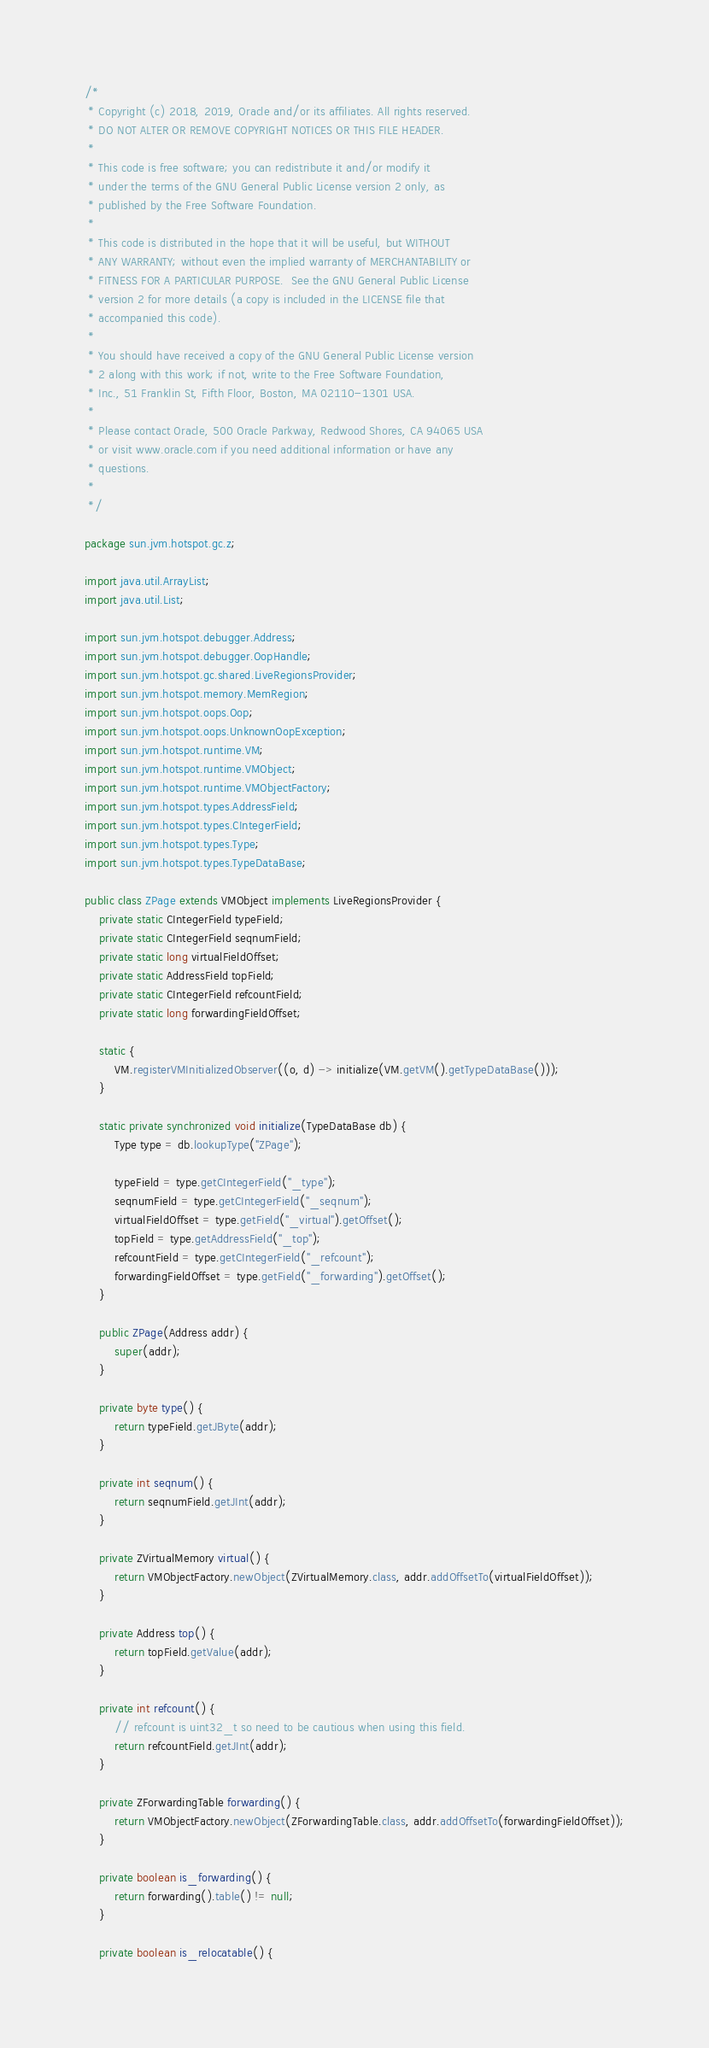<code> <loc_0><loc_0><loc_500><loc_500><_Java_>/*
 * Copyright (c) 2018, 2019, Oracle and/or its affiliates. All rights reserved.
 * DO NOT ALTER OR REMOVE COPYRIGHT NOTICES OR THIS FILE HEADER.
 *
 * This code is free software; you can redistribute it and/or modify it
 * under the terms of the GNU General Public License version 2 only, as
 * published by the Free Software Foundation.
 *
 * This code is distributed in the hope that it will be useful, but WITHOUT
 * ANY WARRANTY; without even the implied warranty of MERCHANTABILITY or
 * FITNESS FOR A PARTICULAR PURPOSE.  See the GNU General Public License
 * version 2 for more details (a copy is included in the LICENSE file that
 * accompanied this code).
 *
 * You should have received a copy of the GNU General Public License version
 * 2 along with this work; if not, write to the Free Software Foundation,
 * Inc., 51 Franklin St, Fifth Floor, Boston, MA 02110-1301 USA.
 *
 * Please contact Oracle, 500 Oracle Parkway, Redwood Shores, CA 94065 USA
 * or visit www.oracle.com if you need additional information or have any
 * questions.
 *
 */

package sun.jvm.hotspot.gc.z;

import java.util.ArrayList;
import java.util.List;

import sun.jvm.hotspot.debugger.Address;
import sun.jvm.hotspot.debugger.OopHandle;
import sun.jvm.hotspot.gc.shared.LiveRegionsProvider;
import sun.jvm.hotspot.memory.MemRegion;
import sun.jvm.hotspot.oops.Oop;
import sun.jvm.hotspot.oops.UnknownOopException;
import sun.jvm.hotspot.runtime.VM;
import sun.jvm.hotspot.runtime.VMObject;
import sun.jvm.hotspot.runtime.VMObjectFactory;
import sun.jvm.hotspot.types.AddressField;
import sun.jvm.hotspot.types.CIntegerField;
import sun.jvm.hotspot.types.Type;
import sun.jvm.hotspot.types.TypeDataBase;

public class ZPage extends VMObject implements LiveRegionsProvider {
    private static CIntegerField typeField;
    private static CIntegerField seqnumField;
    private static long virtualFieldOffset;
    private static AddressField topField;
    private static CIntegerField refcountField;
    private static long forwardingFieldOffset;

    static {
        VM.registerVMInitializedObserver((o, d) -> initialize(VM.getVM().getTypeDataBase()));
    }

    static private synchronized void initialize(TypeDataBase db) {
        Type type = db.lookupType("ZPage");

        typeField = type.getCIntegerField("_type");
        seqnumField = type.getCIntegerField("_seqnum");
        virtualFieldOffset = type.getField("_virtual").getOffset();
        topField = type.getAddressField("_top");
        refcountField = type.getCIntegerField("_refcount");
        forwardingFieldOffset = type.getField("_forwarding").getOffset();
    }

    public ZPage(Address addr) {
        super(addr);
    }

    private byte type() {
        return typeField.getJByte(addr);
    }

    private int seqnum() {
        return seqnumField.getJInt(addr);
    }

    private ZVirtualMemory virtual() {
        return VMObjectFactory.newObject(ZVirtualMemory.class, addr.addOffsetTo(virtualFieldOffset));
    }

    private Address top() {
        return topField.getValue(addr);
    }

    private int refcount() {
        // refcount is uint32_t so need to be cautious when using this field.
        return refcountField.getJInt(addr);
    }

    private ZForwardingTable forwarding() {
        return VMObjectFactory.newObject(ZForwardingTable.class, addr.addOffsetTo(forwardingFieldOffset));
    }

    private boolean is_forwarding() {
        return forwarding().table() != null;
    }

    private boolean is_relocatable() {</code> 